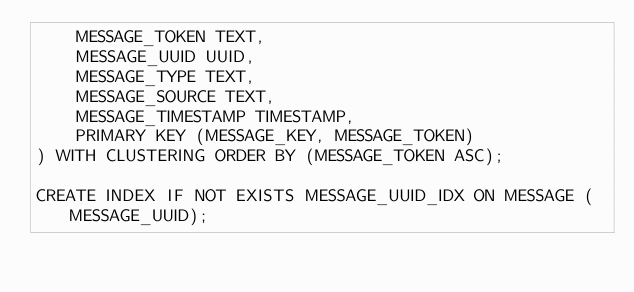<code> <loc_0><loc_0><loc_500><loc_500><_SQL_>    MESSAGE_TOKEN TEXT,
    MESSAGE_UUID UUID,
    MESSAGE_TYPE TEXT,
    MESSAGE_SOURCE TEXT,
    MESSAGE_TIMESTAMP TIMESTAMP,
    PRIMARY KEY (MESSAGE_KEY, MESSAGE_TOKEN)
) WITH CLUSTERING ORDER BY (MESSAGE_TOKEN ASC);

CREATE INDEX IF NOT EXISTS MESSAGE_UUID_IDX ON MESSAGE (MESSAGE_UUID);
</code> 